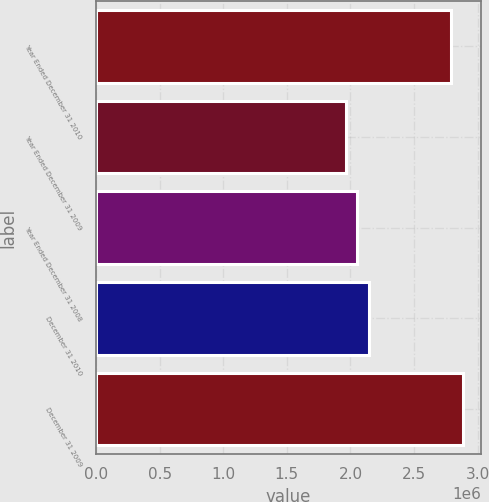Convert chart. <chart><loc_0><loc_0><loc_500><loc_500><bar_chart><fcel>Year Ended December 31 2010<fcel>Year Ended December 31 2009<fcel>Year Ended December 31 2008<fcel>December 31 2010<fcel>December 31 2009<nl><fcel>2.79142e+06<fcel>1.96434e+06<fcel>2.05452e+06<fcel>2.14471e+06<fcel>2.8816e+06<nl></chart> 